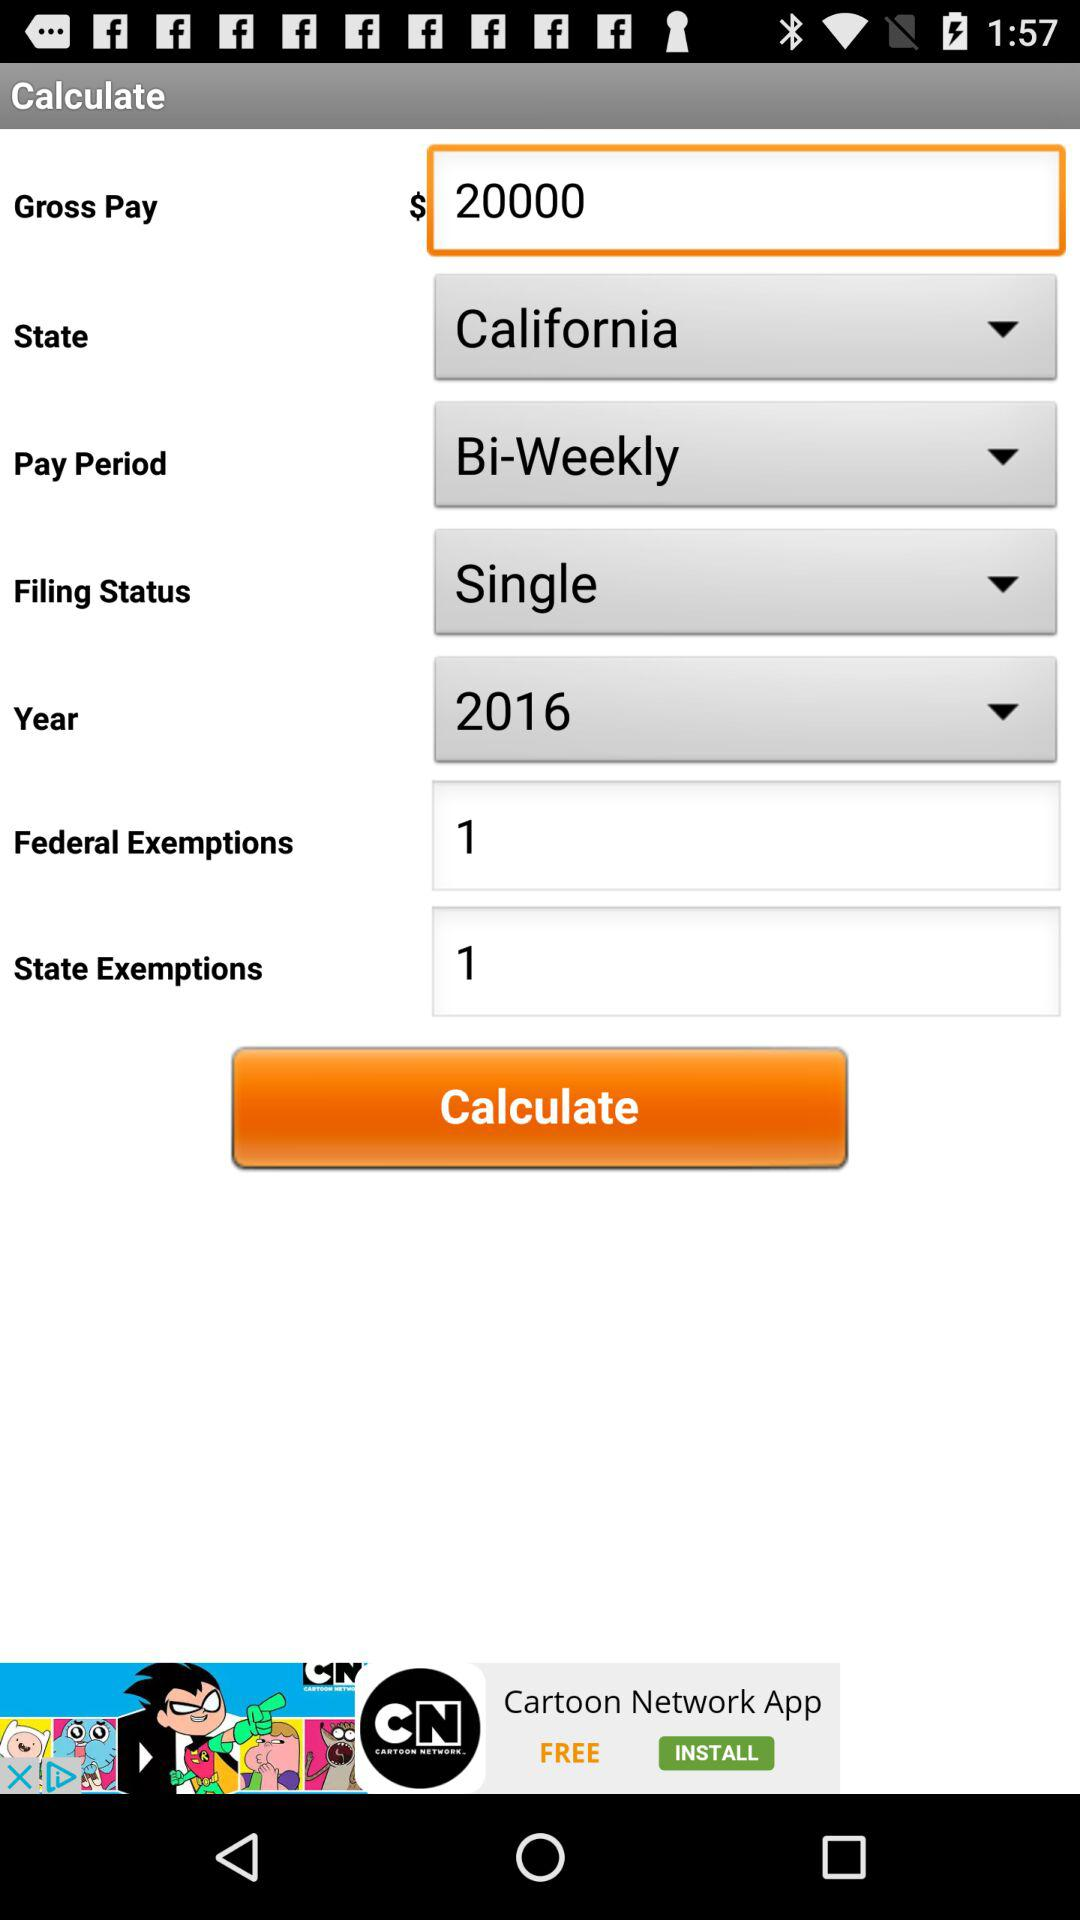Which "Filing Status" has been chosen? The chosen filing status is "Single". 